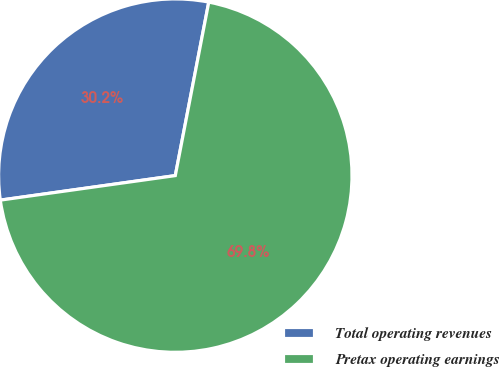Convert chart. <chart><loc_0><loc_0><loc_500><loc_500><pie_chart><fcel>Total operating revenues<fcel>Pretax operating earnings<nl><fcel>30.25%<fcel>69.75%<nl></chart> 